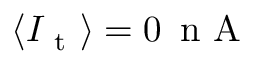Convert formula to latex. <formula><loc_0><loc_0><loc_500><loc_500>\langle I _ { t } \rangle = 0 \, n A</formula> 